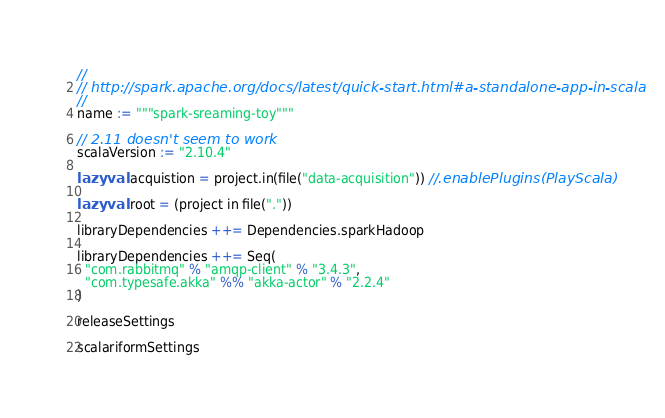Convert code to text. <code><loc_0><loc_0><loc_500><loc_500><_Scala_>//
// http://spark.apache.org/docs/latest/quick-start.html#a-standalone-app-in-scala
//
name := """spark-sreaming-toy"""

// 2.11 doesn't seem to work
scalaVersion := "2.10.4"

lazy val acquistion = project.in(file("data-acquisition")) //.enablePlugins(PlayScala)

lazy val root = (project in file("."))

libraryDependencies ++= Dependencies.sparkHadoop

libraryDependencies ++= Seq(
  "com.rabbitmq" % "amqp-client" % "3.4.3",
  "com.typesafe.akka" %% "akka-actor" % "2.2.4"
)

releaseSettings

scalariformSettings
</code> 